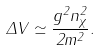<formula> <loc_0><loc_0><loc_500><loc_500>\Delta V \simeq \frac { g ^ { 2 } n _ { \chi } ^ { 2 } } { 2 m ^ { 2 } } .</formula> 